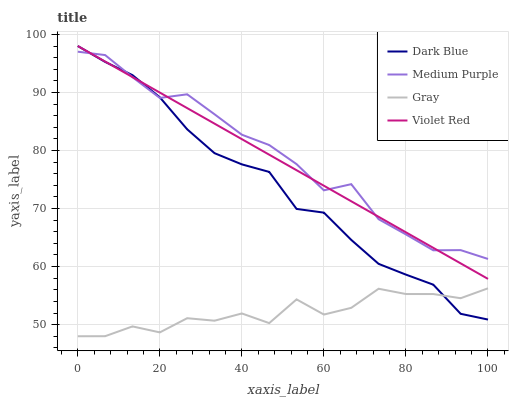Does Gray have the minimum area under the curve?
Answer yes or no. Yes. Does Medium Purple have the maximum area under the curve?
Answer yes or no. Yes. Does Dark Blue have the minimum area under the curve?
Answer yes or no. No. Does Dark Blue have the maximum area under the curve?
Answer yes or no. No. Is Violet Red the smoothest?
Answer yes or no. Yes. Is Gray the roughest?
Answer yes or no. Yes. Is Dark Blue the smoothest?
Answer yes or no. No. Is Dark Blue the roughest?
Answer yes or no. No. Does Dark Blue have the lowest value?
Answer yes or no. No. Does Violet Red have the highest value?
Answer yes or no. Yes. Does Gray have the highest value?
Answer yes or no. No. Is Gray less than Violet Red?
Answer yes or no. Yes. Is Violet Red greater than Gray?
Answer yes or no. Yes. Does Violet Red intersect Medium Purple?
Answer yes or no. Yes. Is Violet Red less than Medium Purple?
Answer yes or no. No. Is Violet Red greater than Medium Purple?
Answer yes or no. No. Does Gray intersect Violet Red?
Answer yes or no. No. 